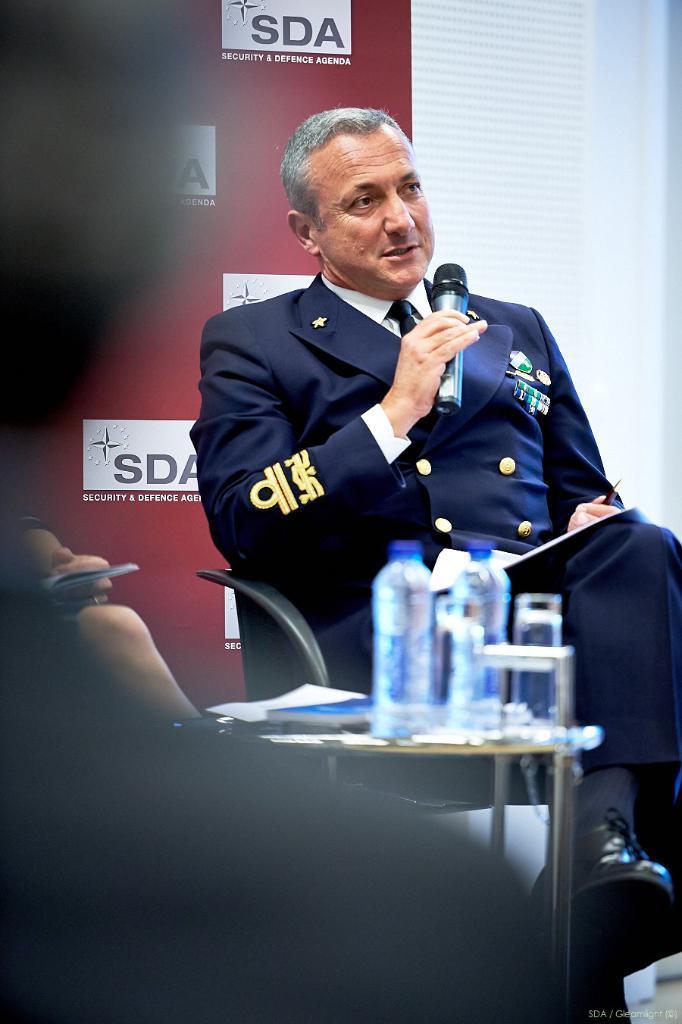Describe this image in one or two sentences. In this picture we can see man holding mic in his hand and talking with paper on him aside to him there is table and on table we can see bottles, book and some person sitting on chair and in background we can see banner. 